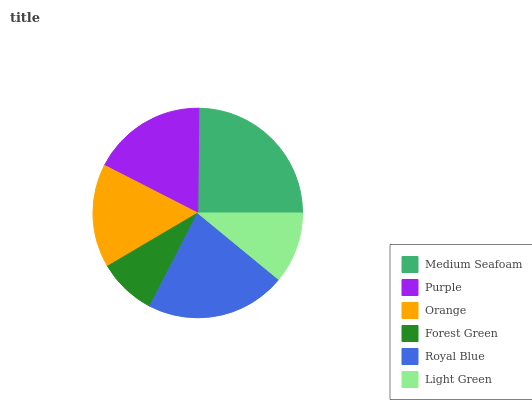Is Forest Green the minimum?
Answer yes or no. Yes. Is Medium Seafoam the maximum?
Answer yes or no. Yes. Is Purple the minimum?
Answer yes or no. No. Is Purple the maximum?
Answer yes or no. No. Is Medium Seafoam greater than Purple?
Answer yes or no. Yes. Is Purple less than Medium Seafoam?
Answer yes or no. Yes. Is Purple greater than Medium Seafoam?
Answer yes or no. No. Is Medium Seafoam less than Purple?
Answer yes or no. No. Is Purple the high median?
Answer yes or no. Yes. Is Orange the low median?
Answer yes or no. Yes. Is Orange the high median?
Answer yes or no. No. Is Purple the low median?
Answer yes or no. No. 